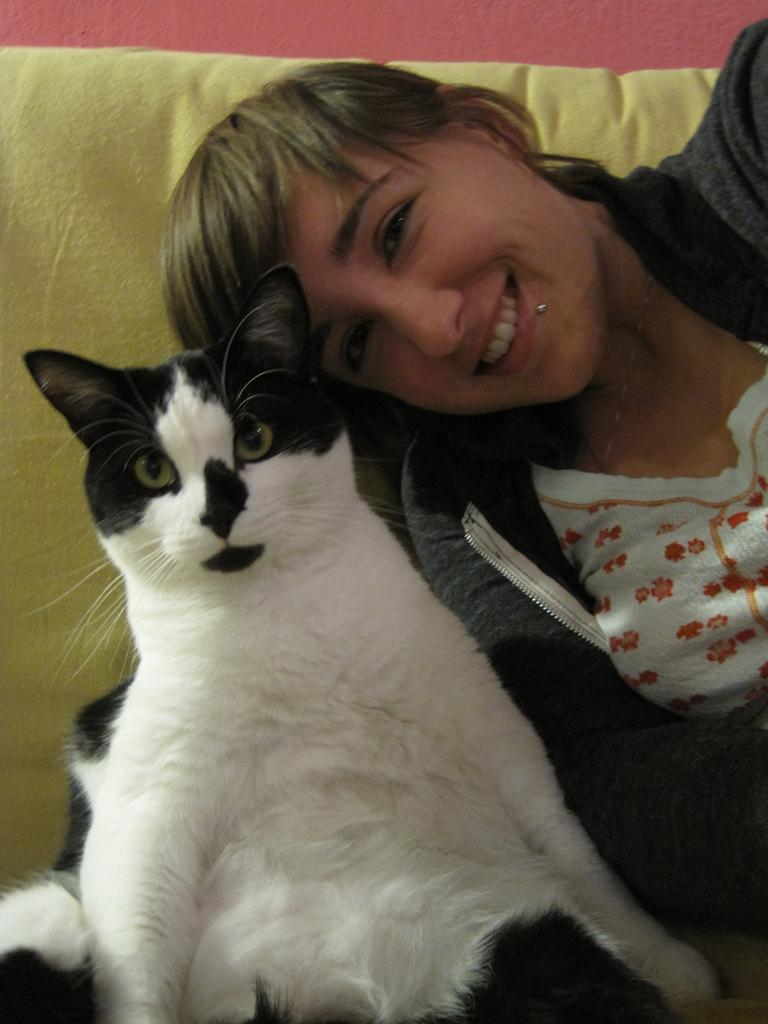Who is present in the image? There is a woman in the image. What is the woman doing in the image? The woman is sitting on a couch. Is there any other living creature in the image besides the woman? Yes, there is a cat in the image. What is the cat doing in the image? The cat is sitting on the couch. How many plates are visible in the image? There are no plates visible in the image. Are there any monkeys present in the image? No, there are no monkeys present in the image. 